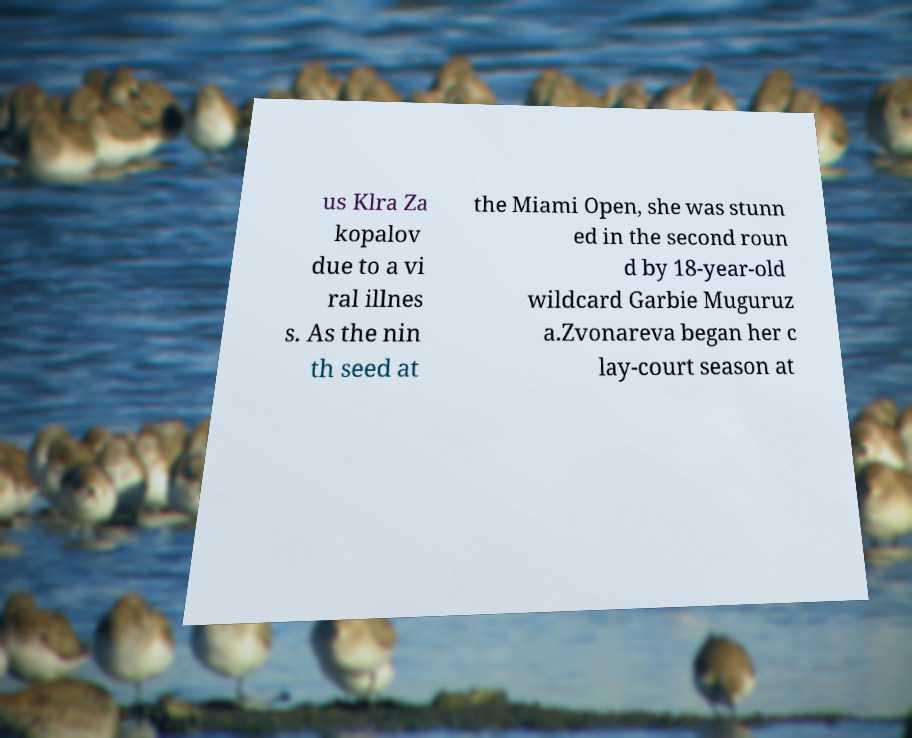Please identify and transcribe the text found in this image. us Klra Za kopalov due to a vi ral illnes s. As the nin th seed at the Miami Open, she was stunn ed in the second roun d by 18-year-old wildcard Garbie Muguruz a.Zvonareva began her c lay-court season at 